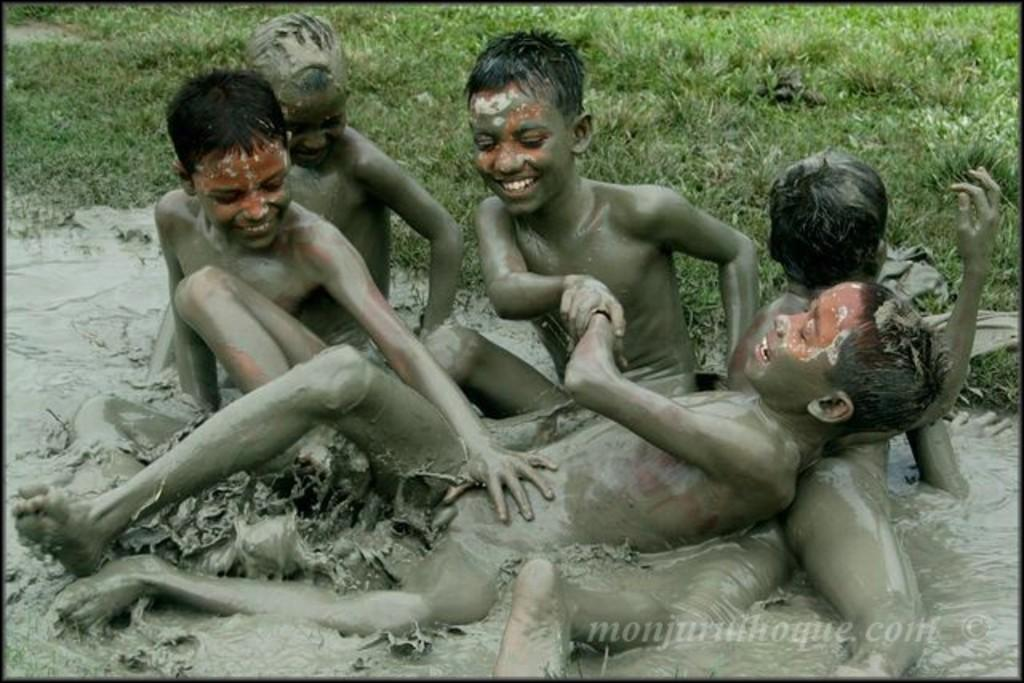What are the kids in the image doing? The kids are playing in the image. In what type of environment are the kids playing? The kids are playing in mud water. What type of terrain is visible at the top of the image? There is grassland visible at the top of the image. What type of afterthought can be seen in the image? There is no afterthought present in the image; it features kids playing in mud water. What type of pleasure can be seen being derived from the river in the image? There is no river present in the image, and therefore no pleasure derived from it can be observed. 